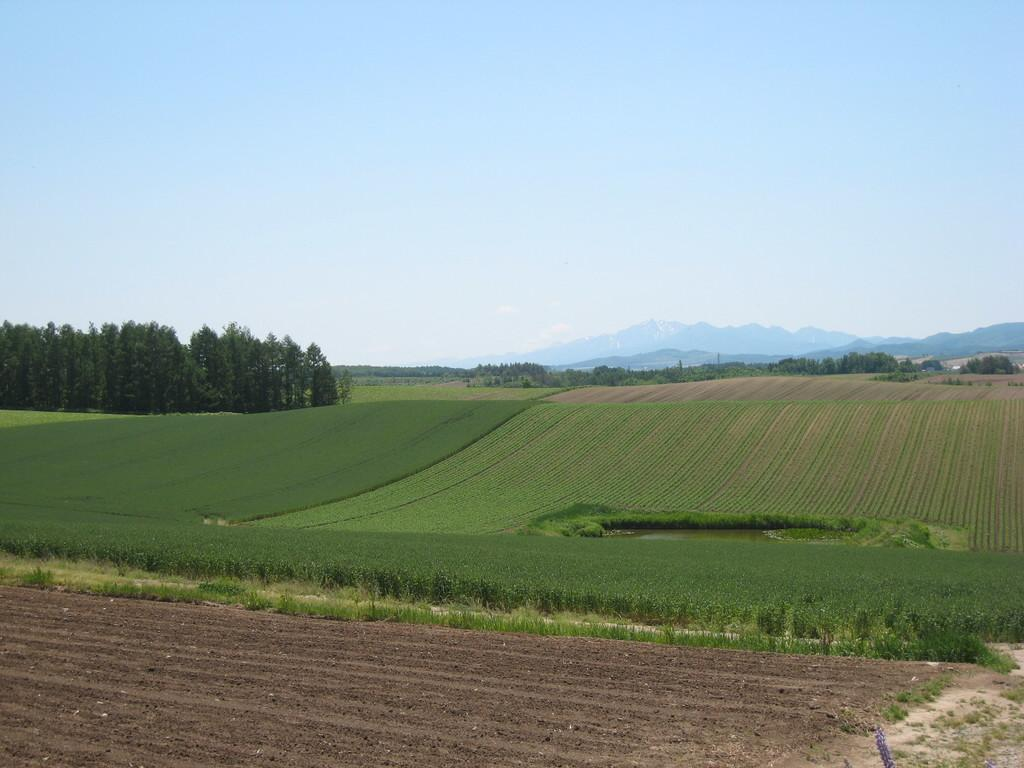What type of vegetation is present in the image? There is a group of plants and a group of trees in the image. What can be seen in the image besides the vegetation? There is water visible in the image. What is visible in the background of the image? There are hills and the sky visible in the background of the image. How would you describe the sky in the image? The sky appears to be cloudy in the image. Can you see any berries growing on the plants in the image? There is no mention of berries in the image, so we cannot determine if they are present or not. Are there any animals with fangs visible in the image? There are no animals, let alone ones with fangs, mentioned or visible in the image. 